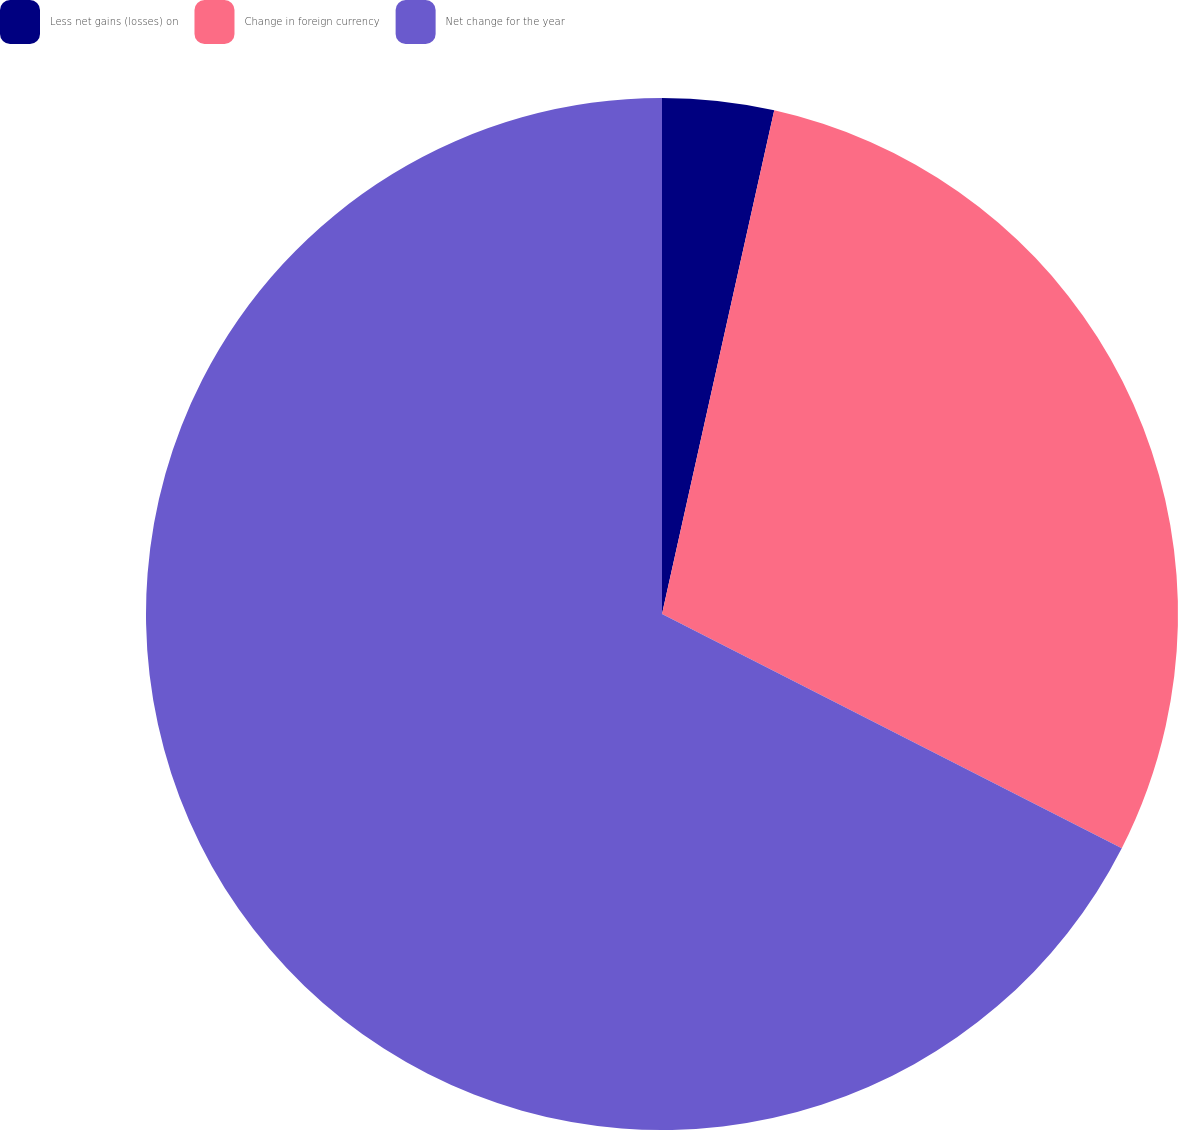<chart> <loc_0><loc_0><loc_500><loc_500><pie_chart><fcel>Less net gains (losses) on<fcel>Change in foreign currency<fcel>Net change for the year<nl><fcel>3.49%<fcel>29.01%<fcel>67.5%<nl></chart> 